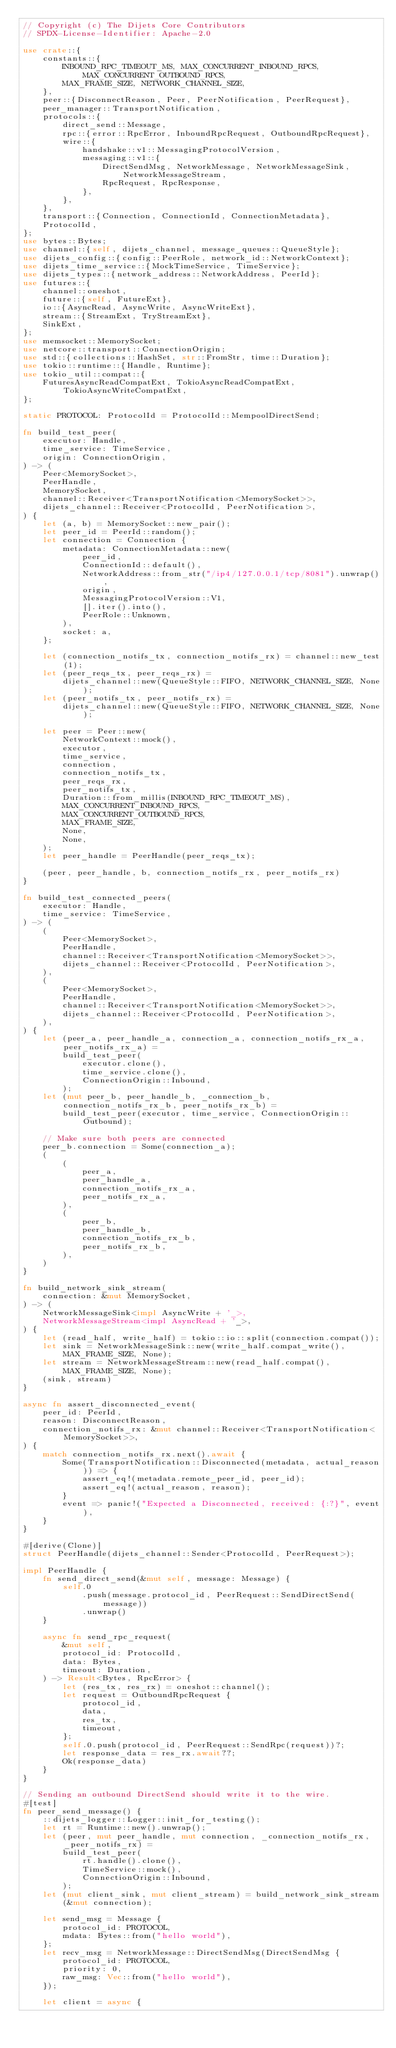<code> <loc_0><loc_0><loc_500><loc_500><_Rust_>// Copyright (c) The Dijets Core Contributors
// SPDX-License-Identifier: Apache-2.0

use crate::{
    constants::{
        INBOUND_RPC_TIMEOUT_MS, MAX_CONCURRENT_INBOUND_RPCS, MAX_CONCURRENT_OUTBOUND_RPCS,
        MAX_FRAME_SIZE, NETWORK_CHANNEL_SIZE,
    },
    peer::{DisconnectReason, Peer, PeerNotification, PeerRequest},
    peer_manager::TransportNotification,
    protocols::{
        direct_send::Message,
        rpc::{error::RpcError, InboundRpcRequest, OutboundRpcRequest},
        wire::{
            handshake::v1::MessagingProtocolVersion,
            messaging::v1::{
                DirectSendMsg, NetworkMessage, NetworkMessageSink, NetworkMessageStream,
                RpcRequest, RpcResponse,
            },
        },
    },
    transport::{Connection, ConnectionId, ConnectionMetadata},
    ProtocolId,
};
use bytes::Bytes;
use channel::{self, dijets_channel, message_queues::QueueStyle};
use dijets_config::{config::PeerRole, network_id::NetworkContext};
use dijets_time_service::{MockTimeService, TimeService};
use dijets_types::{network_address::NetworkAddress, PeerId};
use futures::{
    channel::oneshot,
    future::{self, FutureExt},
    io::{AsyncRead, AsyncWrite, AsyncWriteExt},
    stream::{StreamExt, TryStreamExt},
    SinkExt,
};
use memsocket::MemorySocket;
use netcore::transport::ConnectionOrigin;
use std::{collections::HashSet, str::FromStr, time::Duration};
use tokio::runtime::{Handle, Runtime};
use tokio_util::compat::{
    FuturesAsyncReadCompatExt, TokioAsyncReadCompatExt, TokioAsyncWriteCompatExt,
};

static PROTOCOL: ProtocolId = ProtocolId::MempoolDirectSend;

fn build_test_peer(
    executor: Handle,
    time_service: TimeService,
    origin: ConnectionOrigin,
) -> (
    Peer<MemorySocket>,
    PeerHandle,
    MemorySocket,
    channel::Receiver<TransportNotification<MemorySocket>>,
    dijets_channel::Receiver<ProtocolId, PeerNotification>,
) {
    let (a, b) = MemorySocket::new_pair();
    let peer_id = PeerId::random();
    let connection = Connection {
        metadata: ConnectionMetadata::new(
            peer_id,
            ConnectionId::default(),
            NetworkAddress::from_str("/ip4/127.0.0.1/tcp/8081").unwrap(),
            origin,
            MessagingProtocolVersion::V1,
            [].iter().into(),
            PeerRole::Unknown,
        ),
        socket: a,
    };

    let (connection_notifs_tx, connection_notifs_rx) = channel::new_test(1);
    let (peer_reqs_tx, peer_reqs_rx) =
        dijets_channel::new(QueueStyle::FIFO, NETWORK_CHANNEL_SIZE, None);
    let (peer_notifs_tx, peer_notifs_rx) =
        dijets_channel::new(QueueStyle::FIFO, NETWORK_CHANNEL_SIZE, None);

    let peer = Peer::new(
        NetworkContext::mock(),
        executor,
        time_service,
        connection,
        connection_notifs_tx,
        peer_reqs_rx,
        peer_notifs_tx,
        Duration::from_millis(INBOUND_RPC_TIMEOUT_MS),
        MAX_CONCURRENT_INBOUND_RPCS,
        MAX_CONCURRENT_OUTBOUND_RPCS,
        MAX_FRAME_SIZE,
        None,
        None,
    );
    let peer_handle = PeerHandle(peer_reqs_tx);

    (peer, peer_handle, b, connection_notifs_rx, peer_notifs_rx)
}

fn build_test_connected_peers(
    executor: Handle,
    time_service: TimeService,
) -> (
    (
        Peer<MemorySocket>,
        PeerHandle,
        channel::Receiver<TransportNotification<MemorySocket>>,
        dijets_channel::Receiver<ProtocolId, PeerNotification>,
    ),
    (
        Peer<MemorySocket>,
        PeerHandle,
        channel::Receiver<TransportNotification<MemorySocket>>,
        dijets_channel::Receiver<ProtocolId, PeerNotification>,
    ),
) {
    let (peer_a, peer_handle_a, connection_a, connection_notifs_rx_a, peer_notifs_rx_a) =
        build_test_peer(
            executor.clone(),
            time_service.clone(),
            ConnectionOrigin::Inbound,
        );
    let (mut peer_b, peer_handle_b, _connection_b, connection_notifs_rx_b, peer_notifs_rx_b) =
        build_test_peer(executor, time_service, ConnectionOrigin::Outbound);

    // Make sure both peers are connected
    peer_b.connection = Some(connection_a);
    (
        (
            peer_a,
            peer_handle_a,
            connection_notifs_rx_a,
            peer_notifs_rx_a,
        ),
        (
            peer_b,
            peer_handle_b,
            connection_notifs_rx_b,
            peer_notifs_rx_b,
        ),
    )
}

fn build_network_sink_stream(
    connection: &mut MemorySocket,
) -> (
    NetworkMessageSink<impl AsyncWrite + '_>,
    NetworkMessageStream<impl AsyncRead + '_>,
) {
    let (read_half, write_half) = tokio::io::split(connection.compat());
    let sink = NetworkMessageSink::new(write_half.compat_write(), MAX_FRAME_SIZE, None);
    let stream = NetworkMessageStream::new(read_half.compat(), MAX_FRAME_SIZE, None);
    (sink, stream)
}

async fn assert_disconnected_event(
    peer_id: PeerId,
    reason: DisconnectReason,
    connection_notifs_rx: &mut channel::Receiver<TransportNotification<MemorySocket>>,
) {
    match connection_notifs_rx.next().await {
        Some(TransportNotification::Disconnected(metadata, actual_reason)) => {
            assert_eq!(metadata.remote_peer_id, peer_id);
            assert_eq!(actual_reason, reason);
        }
        event => panic!("Expected a Disconnected, received: {:?}", event),
    }
}

#[derive(Clone)]
struct PeerHandle(dijets_channel::Sender<ProtocolId, PeerRequest>);

impl PeerHandle {
    fn send_direct_send(&mut self, message: Message) {
        self.0
            .push(message.protocol_id, PeerRequest::SendDirectSend(message))
            .unwrap()
    }

    async fn send_rpc_request(
        &mut self,
        protocol_id: ProtocolId,
        data: Bytes,
        timeout: Duration,
    ) -> Result<Bytes, RpcError> {
        let (res_tx, res_rx) = oneshot::channel();
        let request = OutboundRpcRequest {
            protocol_id,
            data,
            res_tx,
            timeout,
        };
        self.0.push(protocol_id, PeerRequest::SendRpc(request))?;
        let response_data = res_rx.await??;
        Ok(response_data)
    }
}

// Sending an outbound DirectSend should write it to the wire.
#[test]
fn peer_send_message() {
    ::dijets_logger::Logger::init_for_testing();
    let rt = Runtime::new().unwrap();
    let (peer, mut peer_handle, mut connection, _connection_notifs_rx, _peer_notifs_rx) =
        build_test_peer(
            rt.handle().clone(),
            TimeService::mock(),
            ConnectionOrigin::Inbound,
        );
    let (mut client_sink, mut client_stream) = build_network_sink_stream(&mut connection);

    let send_msg = Message {
        protocol_id: PROTOCOL,
        mdata: Bytes::from("hello world"),
    };
    let recv_msg = NetworkMessage::DirectSendMsg(DirectSendMsg {
        protocol_id: PROTOCOL,
        priority: 0,
        raw_msg: Vec::from("hello world"),
    });

    let client = async {</code> 